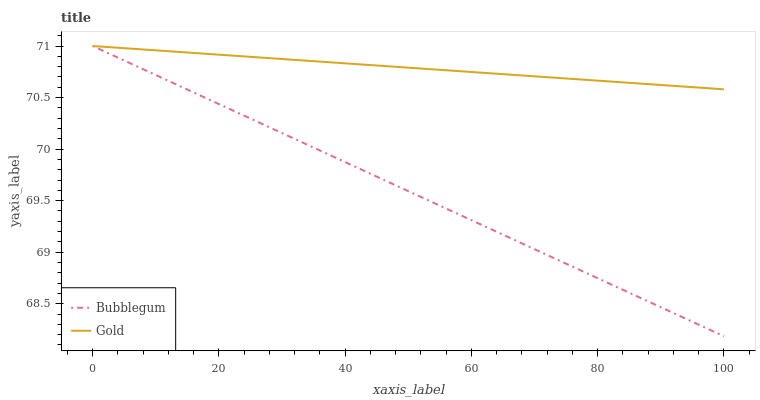Does Bubblegum have the minimum area under the curve?
Answer yes or no. Yes. Does Gold have the maximum area under the curve?
Answer yes or no. Yes. Does Bubblegum have the maximum area under the curve?
Answer yes or no. No. Is Gold the smoothest?
Answer yes or no. Yes. Is Bubblegum the roughest?
Answer yes or no. Yes. Does Bubblegum have the lowest value?
Answer yes or no. Yes. Does Bubblegum have the highest value?
Answer yes or no. Yes. Does Bubblegum intersect Gold?
Answer yes or no. Yes. Is Bubblegum less than Gold?
Answer yes or no. No. Is Bubblegum greater than Gold?
Answer yes or no. No. 